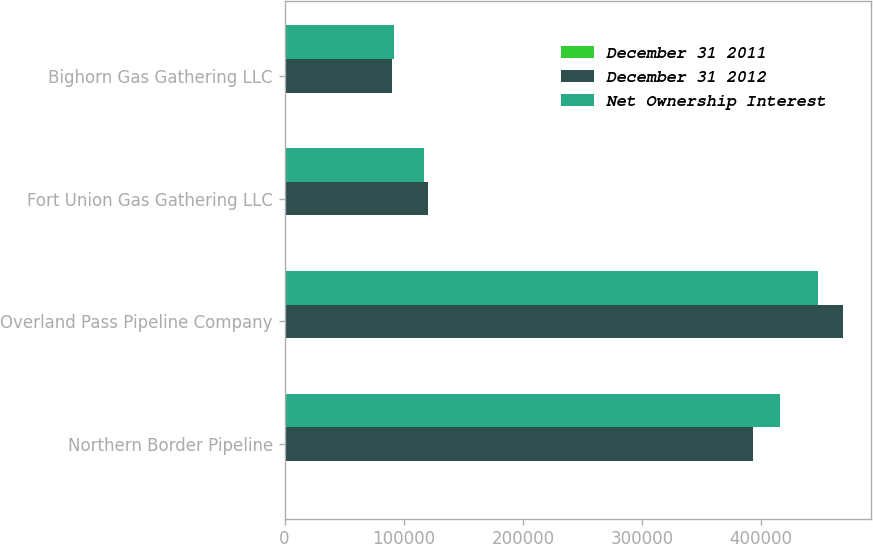<chart> <loc_0><loc_0><loc_500><loc_500><stacked_bar_chart><ecel><fcel>Northern Border Pipeline<fcel>Overland Pass Pipeline Company<fcel>Fort Union Gas Gathering LLC<fcel>Bighorn Gas Gathering LLC<nl><fcel>December 31 2011<fcel>50<fcel>50<fcel>37<fcel>49<nl><fcel>December 31 2012<fcel>393317<fcel>468710<fcel>120782<fcel>90428<nl><fcel>Net Ownership Interest<fcel>416206<fcel>447449<fcel>117353<fcel>91748<nl></chart> 